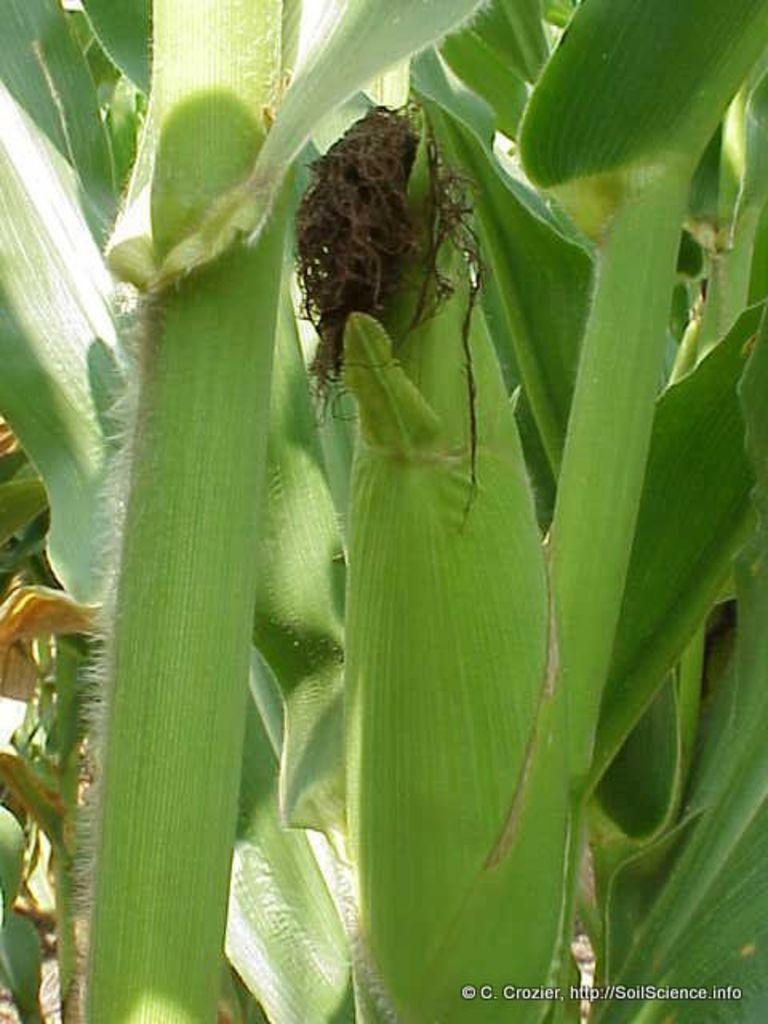What type of plants are visible in the image? There are corn plants in the image. Is there any text present in the image? Yes, there is text at the bottom of the image. What type of grass is growing near the corn plants in the image? There is no grass visible in the image; it only features corn plants. What source of power can be seen in the image? There is no power source visible in the image; it only features corn plants and text. 